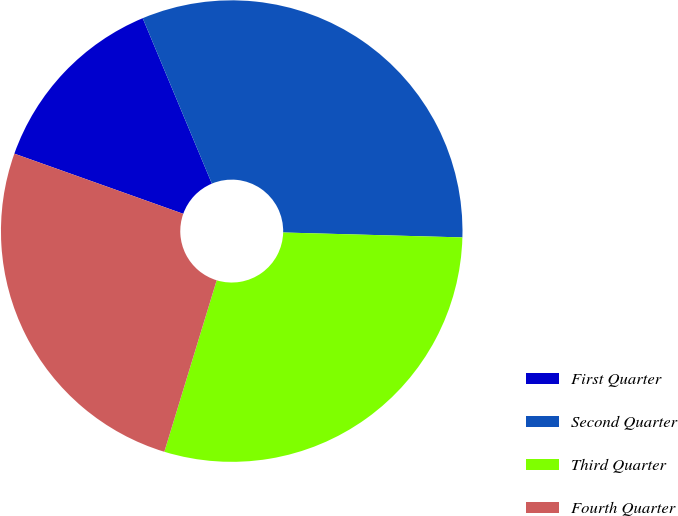Convert chart to OTSL. <chart><loc_0><loc_0><loc_500><loc_500><pie_chart><fcel>First Quarter<fcel>Second Quarter<fcel>Third Quarter<fcel>Fourth Quarter<nl><fcel>13.25%<fcel>31.74%<fcel>29.28%<fcel>25.73%<nl></chart> 